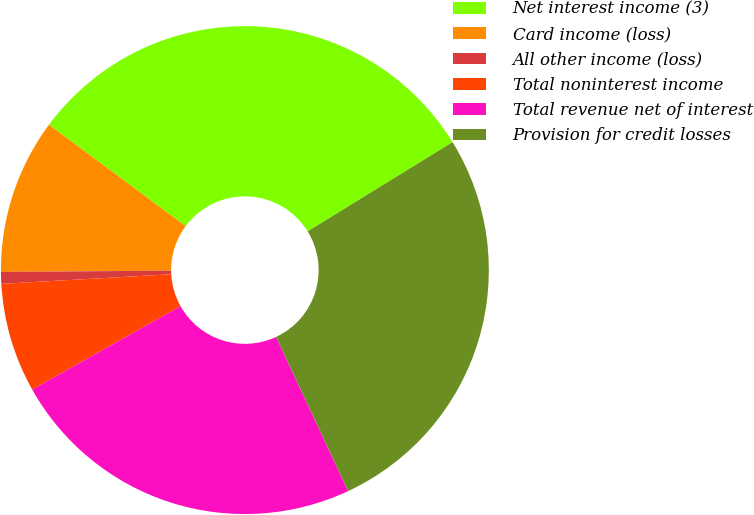Convert chart. <chart><loc_0><loc_0><loc_500><loc_500><pie_chart><fcel>Net interest income (3)<fcel>Card income (loss)<fcel>All other income (loss)<fcel>Total noninterest income<fcel>Total revenue net of interest<fcel>Provision for credit losses<nl><fcel>31.05%<fcel>10.28%<fcel>0.78%<fcel>7.25%<fcel>23.81%<fcel>26.83%<nl></chart> 